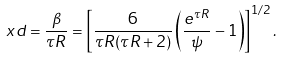Convert formula to latex. <formula><loc_0><loc_0><loc_500><loc_500>\ x d = \frac { \beta } { \tau R } = \left [ \frac { 6 } { \tau R ( \tau R + 2 ) } \left ( \frac { e ^ { \tau R } } { \psi } - 1 \right ) \right ] ^ { 1 / 2 } .</formula> 